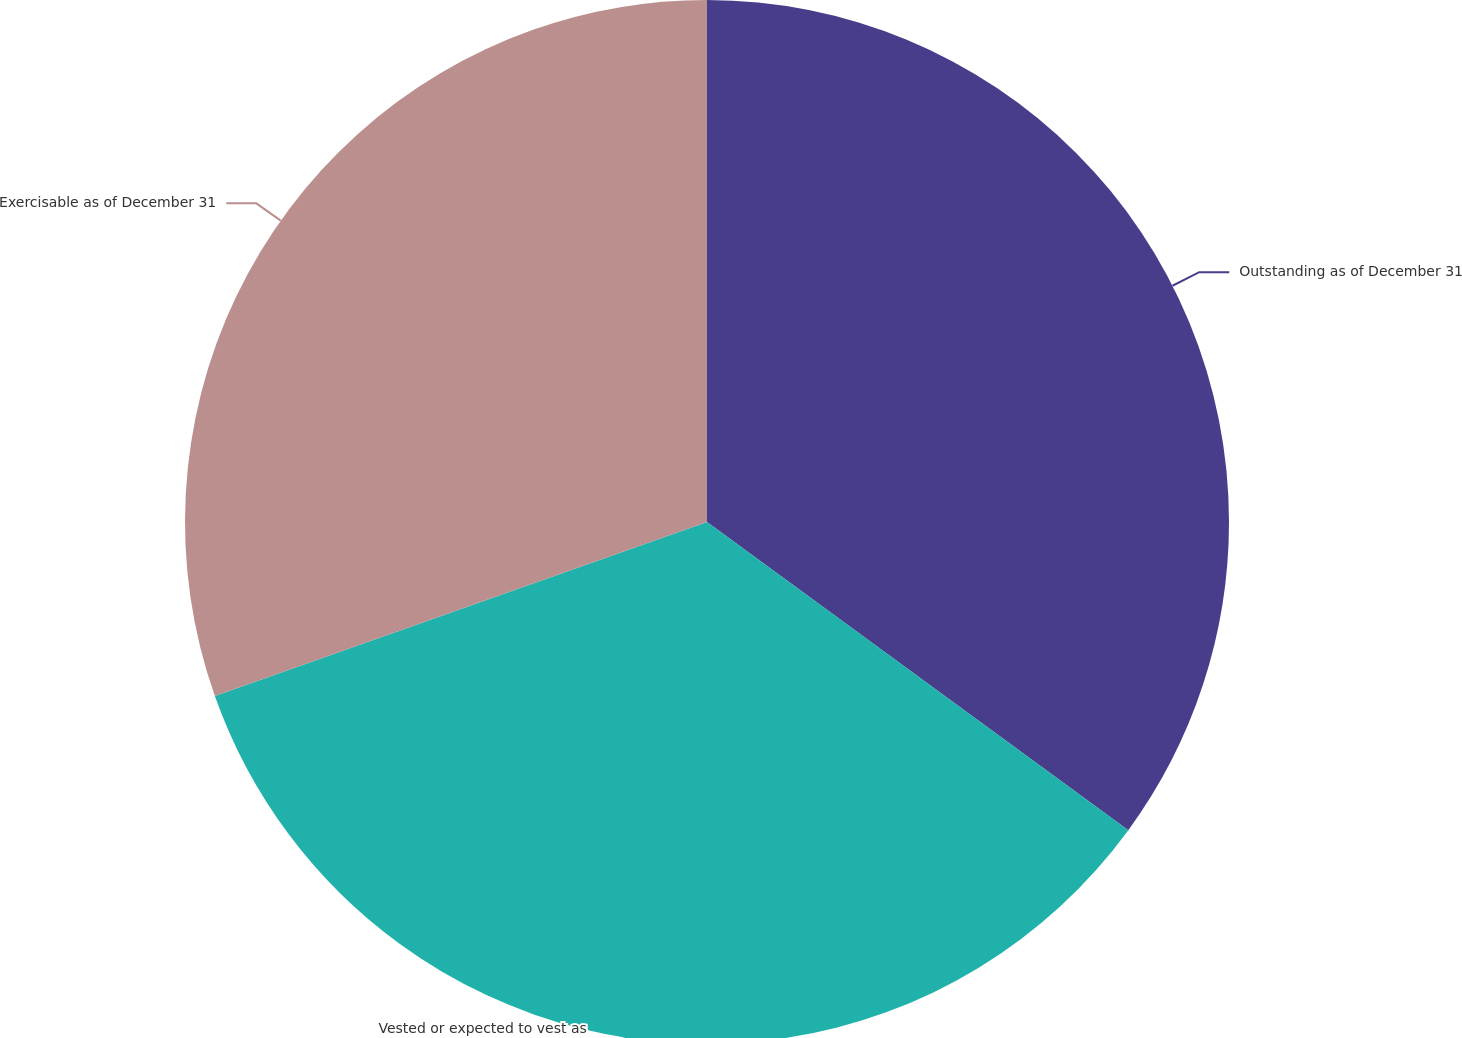Convert chart. <chart><loc_0><loc_0><loc_500><loc_500><pie_chart><fcel>Outstanding as of December 31<fcel>Vested or expected to vest as<fcel>Exercisable as of December 31<nl><fcel>35.05%<fcel>34.54%<fcel>30.41%<nl></chart> 